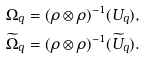<formula> <loc_0><loc_0><loc_500><loc_500>\Omega _ { q } & = ( \rho \otimes \rho ) ^ { - 1 } ( U _ { q } ) , \\ \widetilde { \Omega } _ { q } & = ( \rho \otimes \rho ) ^ { - 1 } ( \widetilde { U } _ { q } ) .</formula> 